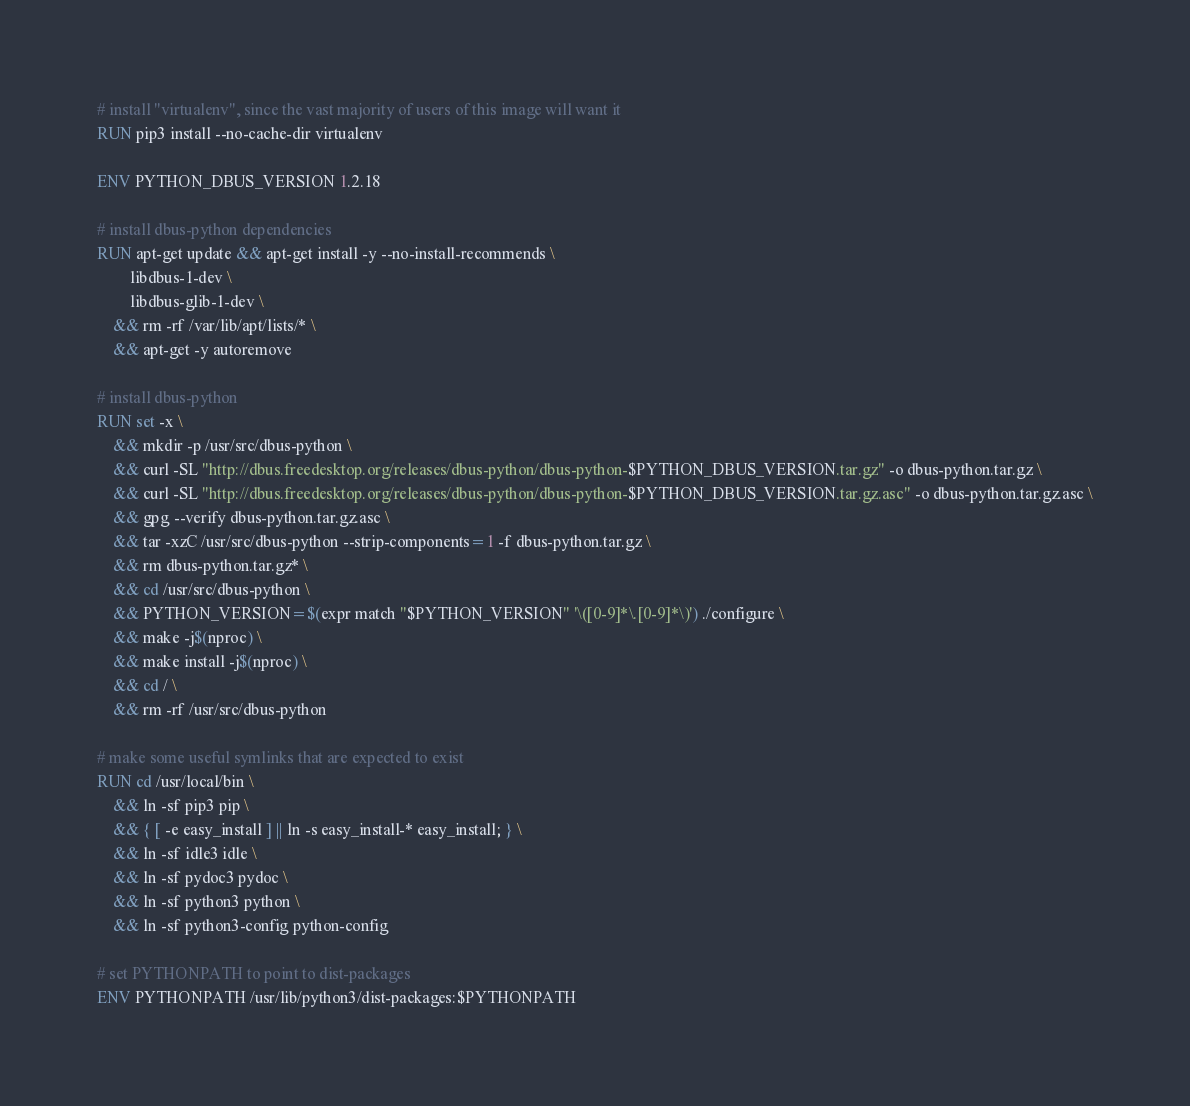<code> <loc_0><loc_0><loc_500><loc_500><_Dockerfile_># install "virtualenv", since the vast majority of users of this image will want it
RUN pip3 install --no-cache-dir virtualenv

ENV PYTHON_DBUS_VERSION 1.2.18

# install dbus-python dependencies 
RUN apt-get update && apt-get install -y --no-install-recommends \
		libdbus-1-dev \
		libdbus-glib-1-dev \
	&& rm -rf /var/lib/apt/lists/* \
	&& apt-get -y autoremove

# install dbus-python
RUN set -x \
	&& mkdir -p /usr/src/dbus-python \
	&& curl -SL "http://dbus.freedesktop.org/releases/dbus-python/dbus-python-$PYTHON_DBUS_VERSION.tar.gz" -o dbus-python.tar.gz \
	&& curl -SL "http://dbus.freedesktop.org/releases/dbus-python/dbus-python-$PYTHON_DBUS_VERSION.tar.gz.asc" -o dbus-python.tar.gz.asc \
	&& gpg --verify dbus-python.tar.gz.asc \
	&& tar -xzC /usr/src/dbus-python --strip-components=1 -f dbus-python.tar.gz \
	&& rm dbus-python.tar.gz* \
	&& cd /usr/src/dbus-python \
	&& PYTHON_VERSION=$(expr match "$PYTHON_VERSION" '\([0-9]*\.[0-9]*\)') ./configure \
	&& make -j$(nproc) \
	&& make install -j$(nproc) \
	&& cd / \
	&& rm -rf /usr/src/dbus-python

# make some useful symlinks that are expected to exist
RUN cd /usr/local/bin \
	&& ln -sf pip3 pip \
	&& { [ -e easy_install ] || ln -s easy_install-* easy_install; } \
	&& ln -sf idle3 idle \
	&& ln -sf pydoc3 pydoc \
	&& ln -sf python3 python \
	&& ln -sf python3-config python-config

# set PYTHONPATH to point to dist-packages
ENV PYTHONPATH /usr/lib/python3/dist-packages:$PYTHONPATH
</code> 